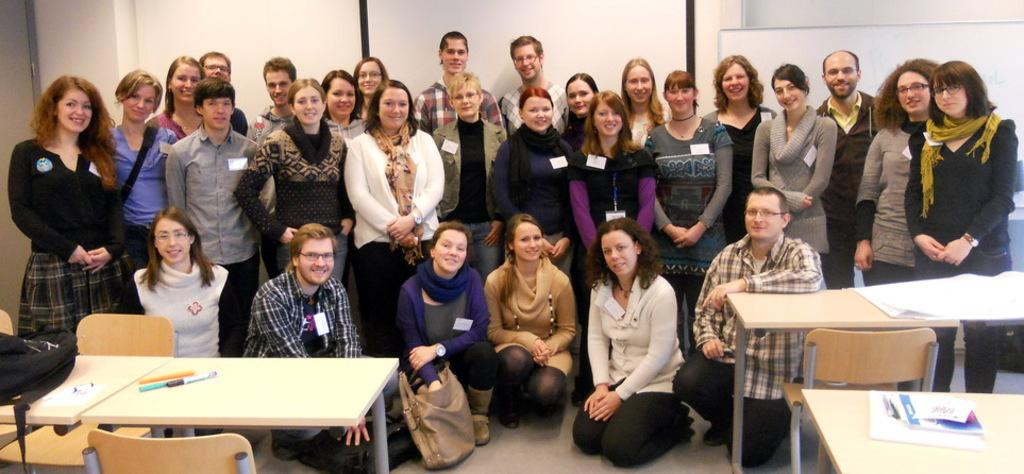How many people are the people are arranged in the image? There is a group of people in the image. What is the main piece of furniture in the image? There is a table in the image. What object related to writing can be seen on the table? There is a pen on the table. What is the seating arrangement in the image? There is a chair in the image. What type of items are related to learning or knowledge in the image? There are books in the image. What type of nut is being cracked by the people in the image? There is no nut present in the image; it features a group of people, a table, a pen, a chair, and books. 